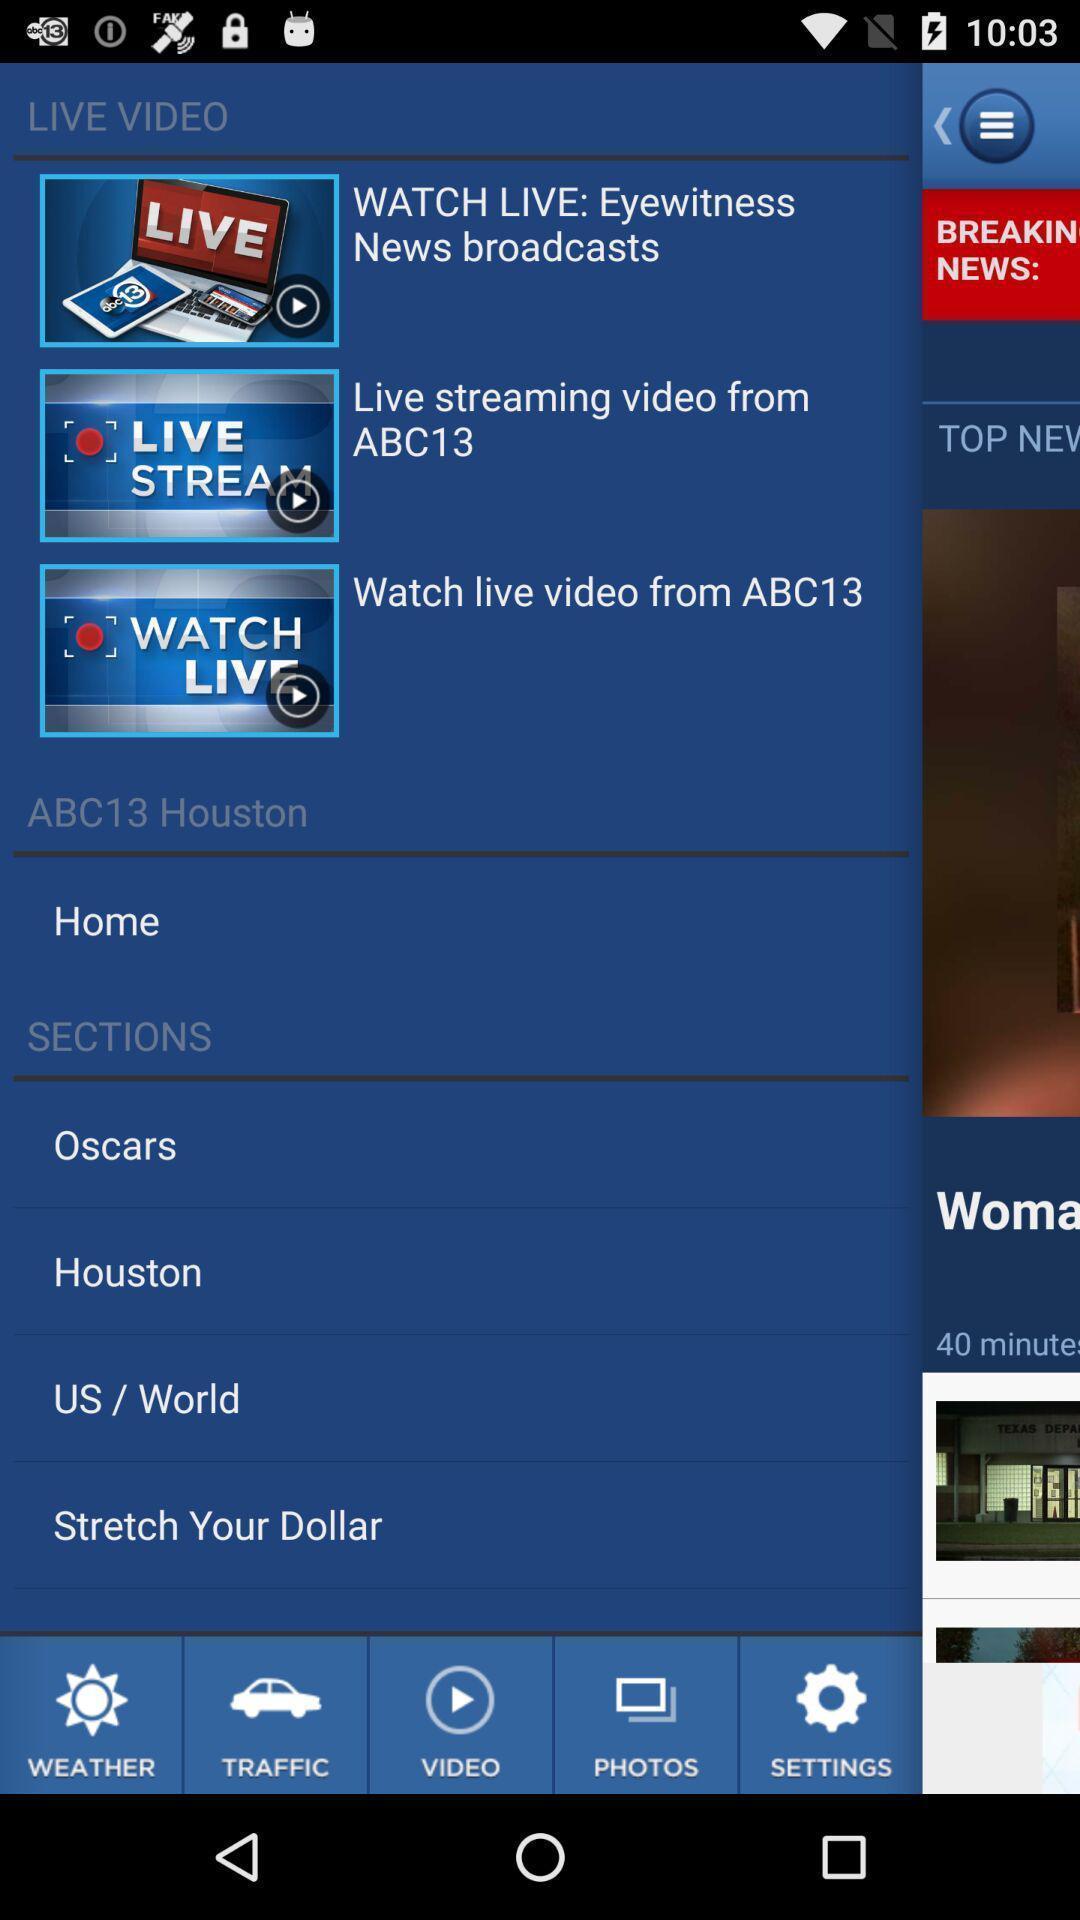What details can you identify in this image? Page showing list of videos. 